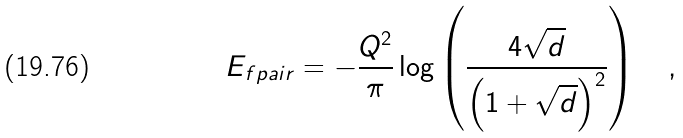<formula> <loc_0><loc_0><loc_500><loc_500>E _ { f p a i r } = - \frac { Q ^ { 2 } } { \pi } \log \left ( \frac { 4 \sqrt { d } } { \left ( 1 + \sqrt { d } \right ) ^ { 2 } } \right ) \quad ,</formula> 